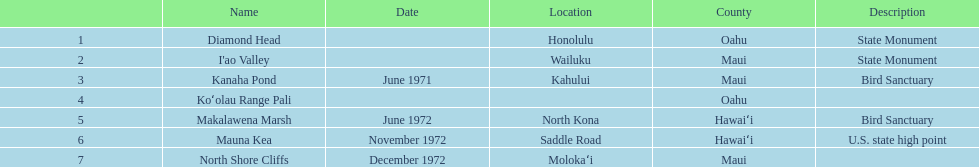What is the total number of images listed? 6. 